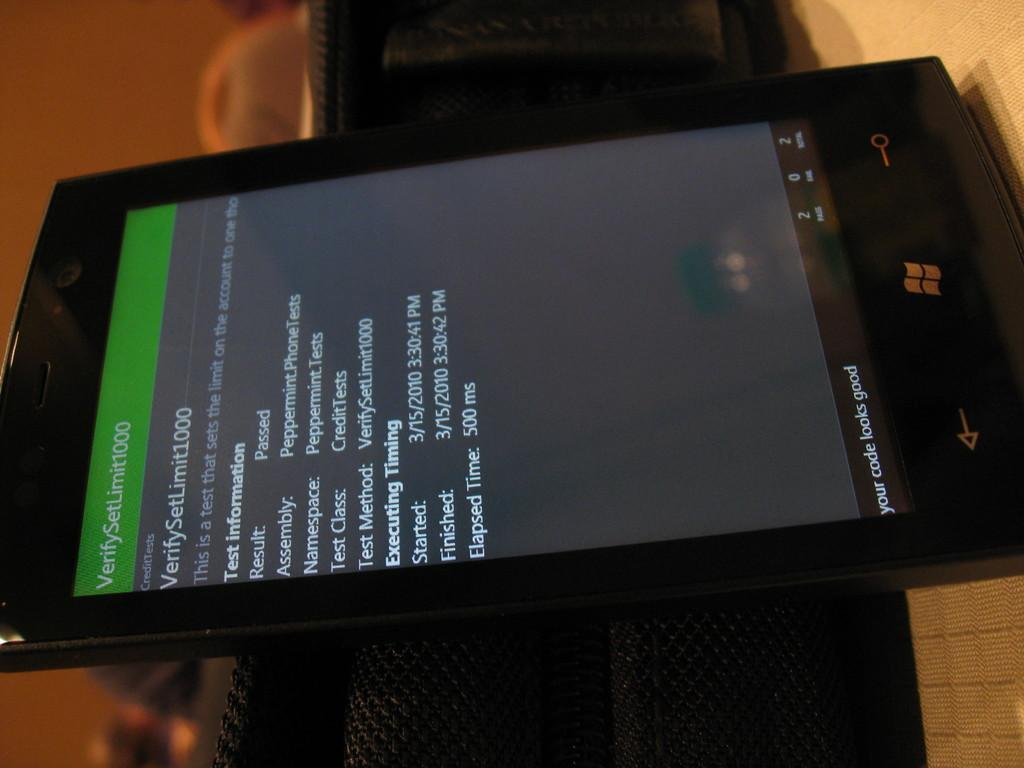Provide a one-sentence caption for the provided image. a tablet with the word Your Code Looks Good on it. 